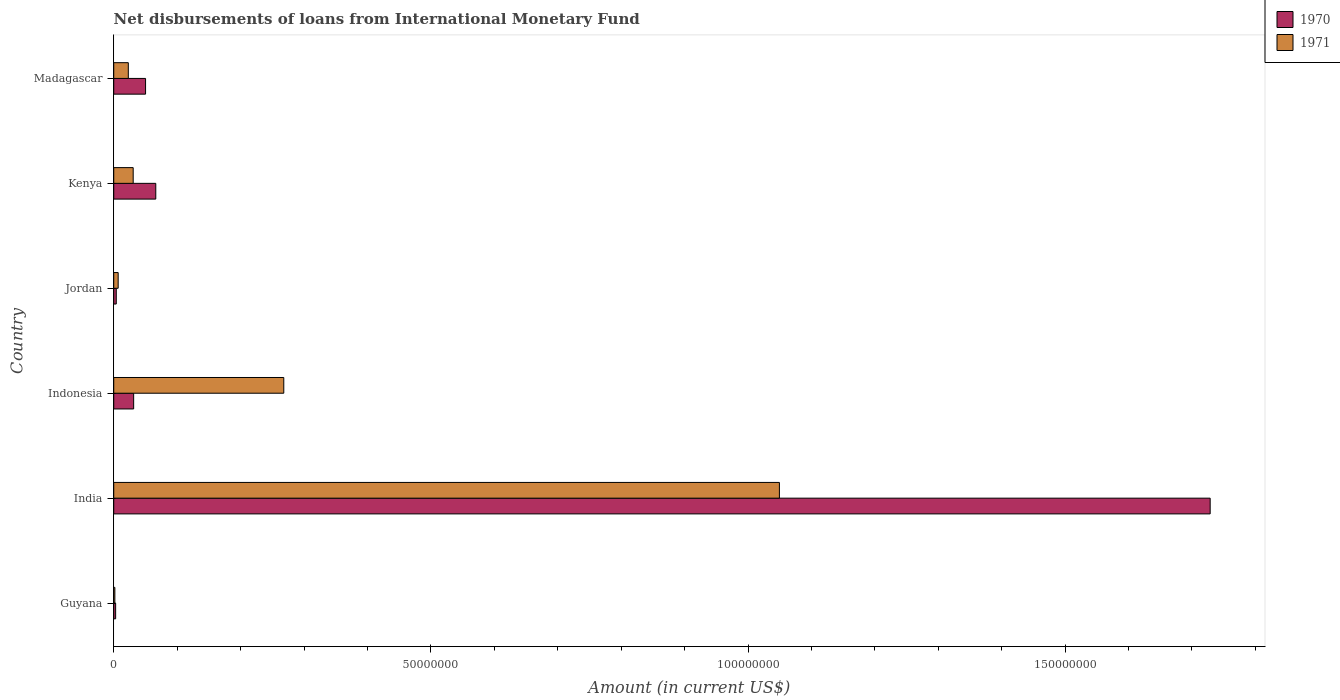How many different coloured bars are there?
Offer a very short reply. 2. Are the number of bars per tick equal to the number of legend labels?
Offer a terse response. Yes. Are the number of bars on each tick of the Y-axis equal?
Give a very brief answer. Yes. What is the amount of loans disbursed in 1971 in India?
Offer a terse response. 1.05e+08. Across all countries, what is the maximum amount of loans disbursed in 1970?
Give a very brief answer. 1.73e+08. Across all countries, what is the minimum amount of loans disbursed in 1970?
Make the answer very short. 2.99e+05. In which country was the amount of loans disbursed in 1970 minimum?
Give a very brief answer. Guyana. What is the total amount of loans disbursed in 1970 in the graph?
Keep it short and to the point. 1.88e+08. What is the difference between the amount of loans disbursed in 1971 in India and that in Jordan?
Your answer should be very brief. 1.04e+08. What is the difference between the amount of loans disbursed in 1970 in Guyana and the amount of loans disbursed in 1971 in Indonesia?
Offer a terse response. -2.65e+07. What is the average amount of loans disbursed in 1970 per country?
Offer a terse response. 3.14e+07. What is the difference between the amount of loans disbursed in 1970 and amount of loans disbursed in 1971 in India?
Provide a short and direct response. 6.79e+07. What is the ratio of the amount of loans disbursed in 1970 in Jordan to that in Kenya?
Your answer should be compact. 0.06. What is the difference between the highest and the second highest amount of loans disbursed in 1971?
Ensure brevity in your answer.  7.81e+07. What is the difference between the highest and the lowest amount of loans disbursed in 1971?
Make the answer very short. 1.05e+08. In how many countries, is the amount of loans disbursed in 1971 greater than the average amount of loans disbursed in 1971 taken over all countries?
Provide a short and direct response. 2. What does the 1st bar from the top in Kenya represents?
Provide a succinct answer. 1971. What does the 1st bar from the bottom in Jordan represents?
Make the answer very short. 1970. How many countries are there in the graph?
Provide a succinct answer. 6. What is the difference between two consecutive major ticks on the X-axis?
Offer a terse response. 5.00e+07. Are the values on the major ticks of X-axis written in scientific E-notation?
Your response must be concise. No. Does the graph contain any zero values?
Ensure brevity in your answer.  No. Where does the legend appear in the graph?
Provide a short and direct response. Top right. How are the legend labels stacked?
Offer a very short reply. Vertical. What is the title of the graph?
Your response must be concise. Net disbursements of loans from International Monetary Fund. What is the label or title of the X-axis?
Provide a short and direct response. Amount (in current US$). What is the label or title of the Y-axis?
Ensure brevity in your answer.  Country. What is the Amount (in current US$) in 1970 in Guyana?
Offer a terse response. 2.99e+05. What is the Amount (in current US$) in 1971 in Guyana?
Ensure brevity in your answer.  1.76e+05. What is the Amount (in current US$) of 1970 in India?
Keep it short and to the point. 1.73e+08. What is the Amount (in current US$) of 1971 in India?
Provide a succinct answer. 1.05e+08. What is the Amount (in current US$) in 1970 in Indonesia?
Your answer should be compact. 3.14e+06. What is the Amount (in current US$) of 1971 in Indonesia?
Your answer should be very brief. 2.68e+07. What is the Amount (in current US$) of 1970 in Jordan?
Ensure brevity in your answer.  3.99e+05. What is the Amount (in current US$) in 1971 in Jordan?
Make the answer very short. 6.99e+05. What is the Amount (in current US$) in 1970 in Kenya?
Offer a very short reply. 6.63e+06. What is the Amount (in current US$) of 1971 in Kenya?
Your answer should be compact. 3.07e+06. What is the Amount (in current US$) of 1970 in Madagascar?
Ensure brevity in your answer.  5.02e+06. What is the Amount (in current US$) in 1971 in Madagascar?
Offer a very short reply. 2.30e+06. Across all countries, what is the maximum Amount (in current US$) in 1970?
Make the answer very short. 1.73e+08. Across all countries, what is the maximum Amount (in current US$) of 1971?
Provide a succinct answer. 1.05e+08. Across all countries, what is the minimum Amount (in current US$) in 1970?
Give a very brief answer. 2.99e+05. Across all countries, what is the minimum Amount (in current US$) in 1971?
Offer a very short reply. 1.76e+05. What is the total Amount (in current US$) in 1970 in the graph?
Your answer should be very brief. 1.88e+08. What is the total Amount (in current US$) in 1971 in the graph?
Ensure brevity in your answer.  1.38e+08. What is the difference between the Amount (in current US$) of 1970 in Guyana and that in India?
Make the answer very short. -1.73e+08. What is the difference between the Amount (in current US$) in 1971 in Guyana and that in India?
Keep it short and to the point. -1.05e+08. What is the difference between the Amount (in current US$) in 1970 in Guyana and that in Indonesia?
Ensure brevity in your answer.  -2.84e+06. What is the difference between the Amount (in current US$) of 1971 in Guyana and that in Indonesia?
Give a very brief answer. -2.66e+07. What is the difference between the Amount (in current US$) of 1971 in Guyana and that in Jordan?
Offer a very short reply. -5.23e+05. What is the difference between the Amount (in current US$) in 1970 in Guyana and that in Kenya?
Your response must be concise. -6.33e+06. What is the difference between the Amount (in current US$) in 1971 in Guyana and that in Kenya?
Provide a short and direct response. -2.89e+06. What is the difference between the Amount (in current US$) in 1970 in Guyana and that in Madagascar?
Your response must be concise. -4.72e+06. What is the difference between the Amount (in current US$) of 1971 in Guyana and that in Madagascar?
Offer a very short reply. -2.12e+06. What is the difference between the Amount (in current US$) of 1970 in India and that in Indonesia?
Keep it short and to the point. 1.70e+08. What is the difference between the Amount (in current US$) of 1971 in India and that in Indonesia?
Offer a very short reply. 7.81e+07. What is the difference between the Amount (in current US$) of 1970 in India and that in Jordan?
Offer a terse response. 1.72e+08. What is the difference between the Amount (in current US$) of 1971 in India and that in Jordan?
Keep it short and to the point. 1.04e+08. What is the difference between the Amount (in current US$) of 1970 in India and that in Kenya?
Your answer should be compact. 1.66e+08. What is the difference between the Amount (in current US$) in 1971 in India and that in Kenya?
Your answer should be very brief. 1.02e+08. What is the difference between the Amount (in current US$) in 1970 in India and that in Madagascar?
Provide a short and direct response. 1.68e+08. What is the difference between the Amount (in current US$) in 1971 in India and that in Madagascar?
Make the answer very short. 1.03e+08. What is the difference between the Amount (in current US$) of 1970 in Indonesia and that in Jordan?
Your answer should be compact. 2.74e+06. What is the difference between the Amount (in current US$) of 1971 in Indonesia and that in Jordan?
Ensure brevity in your answer.  2.61e+07. What is the difference between the Amount (in current US$) of 1970 in Indonesia and that in Kenya?
Your response must be concise. -3.49e+06. What is the difference between the Amount (in current US$) of 1971 in Indonesia and that in Kenya?
Provide a short and direct response. 2.37e+07. What is the difference between the Amount (in current US$) of 1970 in Indonesia and that in Madagascar?
Offer a terse response. -1.88e+06. What is the difference between the Amount (in current US$) of 1971 in Indonesia and that in Madagascar?
Keep it short and to the point. 2.45e+07. What is the difference between the Amount (in current US$) of 1970 in Jordan and that in Kenya?
Provide a succinct answer. -6.23e+06. What is the difference between the Amount (in current US$) in 1971 in Jordan and that in Kenya?
Offer a terse response. -2.37e+06. What is the difference between the Amount (in current US$) in 1970 in Jordan and that in Madagascar?
Offer a terse response. -4.62e+06. What is the difference between the Amount (in current US$) of 1971 in Jordan and that in Madagascar?
Your response must be concise. -1.60e+06. What is the difference between the Amount (in current US$) in 1970 in Kenya and that in Madagascar?
Make the answer very short. 1.61e+06. What is the difference between the Amount (in current US$) in 1971 in Kenya and that in Madagascar?
Your response must be concise. 7.69e+05. What is the difference between the Amount (in current US$) in 1970 in Guyana and the Amount (in current US$) in 1971 in India?
Your answer should be very brief. -1.05e+08. What is the difference between the Amount (in current US$) in 1970 in Guyana and the Amount (in current US$) in 1971 in Indonesia?
Provide a short and direct response. -2.65e+07. What is the difference between the Amount (in current US$) of 1970 in Guyana and the Amount (in current US$) of 1971 in Jordan?
Give a very brief answer. -4.00e+05. What is the difference between the Amount (in current US$) of 1970 in Guyana and the Amount (in current US$) of 1971 in Kenya?
Give a very brief answer. -2.77e+06. What is the difference between the Amount (in current US$) of 1970 in Guyana and the Amount (in current US$) of 1971 in Madagascar?
Ensure brevity in your answer.  -2.00e+06. What is the difference between the Amount (in current US$) in 1970 in India and the Amount (in current US$) in 1971 in Indonesia?
Keep it short and to the point. 1.46e+08. What is the difference between the Amount (in current US$) of 1970 in India and the Amount (in current US$) of 1971 in Jordan?
Your answer should be very brief. 1.72e+08. What is the difference between the Amount (in current US$) of 1970 in India and the Amount (in current US$) of 1971 in Kenya?
Your answer should be compact. 1.70e+08. What is the difference between the Amount (in current US$) of 1970 in India and the Amount (in current US$) of 1971 in Madagascar?
Offer a very short reply. 1.71e+08. What is the difference between the Amount (in current US$) in 1970 in Indonesia and the Amount (in current US$) in 1971 in Jordan?
Your answer should be compact. 2.44e+06. What is the difference between the Amount (in current US$) in 1970 in Indonesia and the Amount (in current US$) in 1971 in Kenya?
Offer a terse response. 7.30e+04. What is the difference between the Amount (in current US$) of 1970 in Indonesia and the Amount (in current US$) of 1971 in Madagascar?
Offer a very short reply. 8.42e+05. What is the difference between the Amount (in current US$) in 1970 in Jordan and the Amount (in current US$) in 1971 in Kenya?
Give a very brief answer. -2.67e+06. What is the difference between the Amount (in current US$) of 1970 in Jordan and the Amount (in current US$) of 1971 in Madagascar?
Provide a succinct answer. -1.90e+06. What is the difference between the Amount (in current US$) in 1970 in Kenya and the Amount (in current US$) in 1971 in Madagascar?
Provide a succinct answer. 4.33e+06. What is the average Amount (in current US$) of 1970 per country?
Provide a succinct answer. 3.14e+07. What is the average Amount (in current US$) in 1971 per country?
Keep it short and to the point. 2.30e+07. What is the difference between the Amount (in current US$) of 1970 and Amount (in current US$) of 1971 in Guyana?
Make the answer very short. 1.23e+05. What is the difference between the Amount (in current US$) in 1970 and Amount (in current US$) in 1971 in India?
Provide a short and direct response. 6.79e+07. What is the difference between the Amount (in current US$) of 1970 and Amount (in current US$) of 1971 in Indonesia?
Provide a succinct answer. -2.37e+07. What is the difference between the Amount (in current US$) of 1970 and Amount (in current US$) of 1971 in Jordan?
Ensure brevity in your answer.  -3.00e+05. What is the difference between the Amount (in current US$) of 1970 and Amount (in current US$) of 1971 in Kenya?
Provide a succinct answer. 3.56e+06. What is the difference between the Amount (in current US$) in 1970 and Amount (in current US$) in 1971 in Madagascar?
Your answer should be very brief. 2.72e+06. What is the ratio of the Amount (in current US$) in 1970 in Guyana to that in India?
Keep it short and to the point. 0. What is the ratio of the Amount (in current US$) in 1971 in Guyana to that in India?
Keep it short and to the point. 0. What is the ratio of the Amount (in current US$) of 1970 in Guyana to that in Indonesia?
Offer a terse response. 0.1. What is the ratio of the Amount (in current US$) in 1971 in Guyana to that in Indonesia?
Your answer should be very brief. 0.01. What is the ratio of the Amount (in current US$) of 1970 in Guyana to that in Jordan?
Make the answer very short. 0.75. What is the ratio of the Amount (in current US$) in 1971 in Guyana to that in Jordan?
Offer a terse response. 0.25. What is the ratio of the Amount (in current US$) of 1970 in Guyana to that in Kenya?
Your response must be concise. 0.05. What is the ratio of the Amount (in current US$) of 1971 in Guyana to that in Kenya?
Your answer should be very brief. 0.06. What is the ratio of the Amount (in current US$) of 1970 in Guyana to that in Madagascar?
Provide a succinct answer. 0.06. What is the ratio of the Amount (in current US$) of 1971 in Guyana to that in Madagascar?
Ensure brevity in your answer.  0.08. What is the ratio of the Amount (in current US$) in 1970 in India to that in Indonesia?
Offer a terse response. 55.07. What is the ratio of the Amount (in current US$) in 1971 in India to that in Indonesia?
Give a very brief answer. 3.91. What is the ratio of the Amount (in current US$) of 1970 in India to that in Jordan?
Give a very brief answer. 433.25. What is the ratio of the Amount (in current US$) of 1971 in India to that in Jordan?
Your answer should be compact. 150.14. What is the ratio of the Amount (in current US$) in 1970 in India to that in Kenya?
Ensure brevity in your answer.  26.08. What is the ratio of the Amount (in current US$) of 1971 in India to that in Kenya?
Ensure brevity in your answer.  34.23. What is the ratio of the Amount (in current US$) in 1970 in India to that in Madagascar?
Ensure brevity in your answer.  34.45. What is the ratio of the Amount (in current US$) in 1971 in India to that in Madagascar?
Offer a terse response. 45.69. What is the ratio of the Amount (in current US$) in 1970 in Indonesia to that in Jordan?
Your response must be concise. 7.87. What is the ratio of the Amount (in current US$) of 1971 in Indonesia to that in Jordan?
Provide a short and direct response. 38.35. What is the ratio of the Amount (in current US$) of 1970 in Indonesia to that in Kenya?
Provide a succinct answer. 0.47. What is the ratio of the Amount (in current US$) in 1971 in Indonesia to that in Kenya?
Offer a terse response. 8.74. What is the ratio of the Amount (in current US$) of 1970 in Indonesia to that in Madagascar?
Provide a succinct answer. 0.63. What is the ratio of the Amount (in current US$) of 1971 in Indonesia to that in Madagascar?
Your answer should be very brief. 11.67. What is the ratio of the Amount (in current US$) of 1970 in Jordan to that in Kenya?
Your answer should be very brief. 0.06. What is the ratio of the Amount (in current US$) in 1971 in Jordan to that in Kenya?
Provide a short and direct response. 0.23. What is the ratio of the Amount (in current US$) of 1970 in Jordan to that in Madagascar?
Ensure brevity in your answer.  0.08. What is the ratio of the Amount (in current US$) in 1971 in Jordan to that in Madagascar?
Make the answer very short. 0.3. What is the ratio of the Amount (in current US$) of 1970 in Kenya to that in Madagascar?
Provide a short and direct response. 1.32. What is the ratio of the Amount (in current US$) in 1971 in Kenya to that in Madagascar?
Ensure brevity in your answer.  1.33. What is the difference between the highest and the second highest Amount (in current US$) in 1970?
Offer a terse response. 1.66e+08. What is the difference between the highest and the second highest Amount (in current US$) in 1971?
Your response must be concise. 7.81e+07. What is the difference between the highest and the lowest Amount (in current US$) in 1970?
Your answer should be very brief. 1.73e+08. What is the difference between the highest and the lowest Amount (in current US$) in 1971?
Keep it short and to the point. 1.05e+08. 